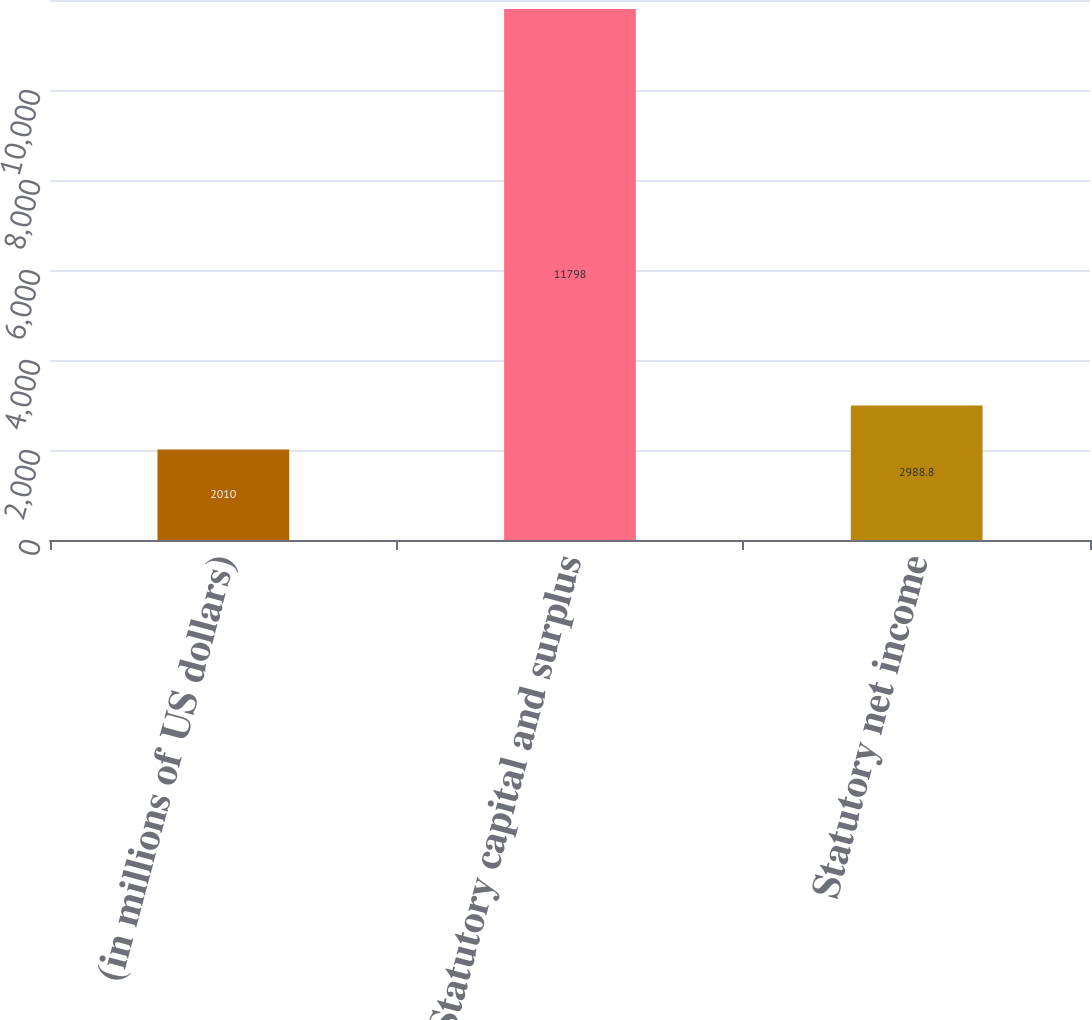Convert chart. <chart><loc_0><loc_0><loc_500><loc_500><bar_chart><fcel>(in millions of US dollars)<fcel>Statutory capital and surplus<fcel>Statutory net income<nl><fcel>2010<fcel>11798<fcel>2988.8<nl></chart> 